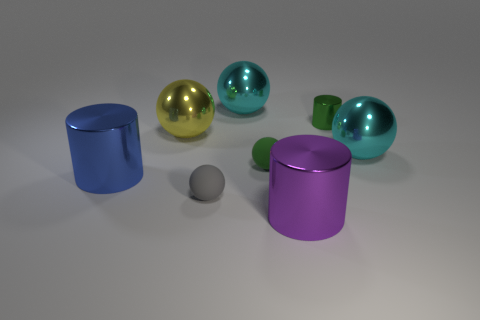There is a purple shiny object; is its shape the same as the green thing that is to the left of the green cylinder?
Your response must be concise. No. What number of things are metallic cylinders that are behind the small gray matte thing or big shiny spheres?
Your answer should be very brief. 5. Do the blue object and the small thing in front of the large blue shiny object have the same material?
Provide a short and direct response. No. There is a rubber thing behind the metal cylinder that is to the left of the big purple metal object; what is its shape?
Make the answer very short. Sphere. Is the color of the small metal cylinder the same as the large thing on the left side of the yellow object?
Give a very brief answer. No. Are there any other things that are made of the same material as the yellow thing?
Offer a very short reply. Yes. What shape is the small gray rubber thing?
Make the answer very short. Sphere. There is a cyan object on the left side of the big cyan sphere that is on the right side of the tiny green cylinder; what is its size?
Provide a short and direct response. Large. Are there an equal number of metal objects that are behind the tiny cylinder and shiny objects that are on the right side of the small gray matte ball?
Keep it short and to the point. No. There is a object that is to the left of the tiny green shiny cylinder and behind the yellow sphere; what is its material?
Your answer should be very brief. Metal. 